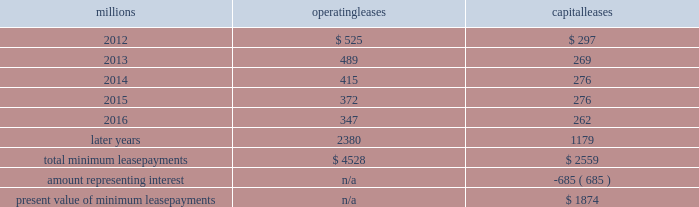The redemptions resulted in an early extinguishment charge of $ 5 million .
On march 22 , 2010 , we redeemed $ 175 million of our 6.5% ( 6.5 % ) notes due april 15 , 2012 .
The redemption resulted in an early extinguishment charge of $ 16 million in the first quarter of 2010 .
On november 1 , 2010 , we redeemed all $ 400 million of our outstanding 6.65% ( 6.65 % ) notes due january 15 , 2011 .
The redemption resulted in a $ 5 million early extinguishment charge .
Receivables securitization facility 2013 as of december 31 , 2011 and 2010 , we have recorded $ 100 million as secured debt under our receivables securitization facility .
( see further discussion of our receivables securitization facility in note 10 ) .
15 .
Variable interest entities we have entered into various lease transactions in which the structure of the leases contain variable interest entities ( vies ) .
These vies were created solely for the purpose of doing lease transactions ( principally involving railroad equipment and facilities , including our headquarters building ) and have no other activities , assets or liabilities outside of the lease transactions .
Within these lease arrangements , we have the right to purchase some or all of the assets at fixed prices .
Depending on market conditions , fixed-price purchase options available in the leases could potentially provide benefits to us ; however , these benefits are not expected to be significant .
We maintain and operate the assets based on contractual obligations within the lease arrangements , which set specific guidelines consistent within the railroad industry .
As such , we have no control over activities that could materially impact the fair value of the leased assets .
We do not hold the power to direct the activities of the vies and , therefore , do not control the ongoing activities that have a significant impact on the economic performance of the vies .
Additionally , we do not have the obligation to absorb losses of the vies or the right to receive benefits of the vies that could potentially be significant to the we are not considered to be the primary beneficiary and do not consolidate these vies because our actions and decisions do not have the most significant effect on the vie 2019s performance and our fixed-price purchase price options are not considered to be potentially significant to the vie 2019s .
The future minimum lease payments associated with the vie leases totaled $ 3.9 billion as of december 31 , 2011 .
16 .
Leases we lease certain locomotives , freight cars , and other property .
The consolidated statement of financial position as of december 31 , 2011 and 2010 included $ 2458 million , net of $ 915 million of accumulated depreciation , and $ 2520 million , net of $ 901 million of accumulated depreciation , respectively , for properties held under capital leases .
A charge to income resulting from the depreciation for assets held under capital leases is included within depreciation expense in our consolidated statements of income .
Future minimum lease payments for operating and capital leases with initial or remaining non-cancelable lease terms in excess of one year as of december 31 , 2011 , were as follows : millions operating leases capital leases .
The majority of capital lease payments relate to locomotives .
Rent expense for operating leases with terms exceeding one month was $ 637 million in 2011 , $ 624 million in 2010 , and $ 686 million in 2009 .
When cash rental payments are not made on a straight-line basis , we recognize variable rental expense on a straight-line basis over the lease term .
Contingent rentals and sub-rentals are not significant. .
What percent of total minimum operating lease payments are due in 2012? 
Computations: (525 / 4528)
Answer: 0.11595. 